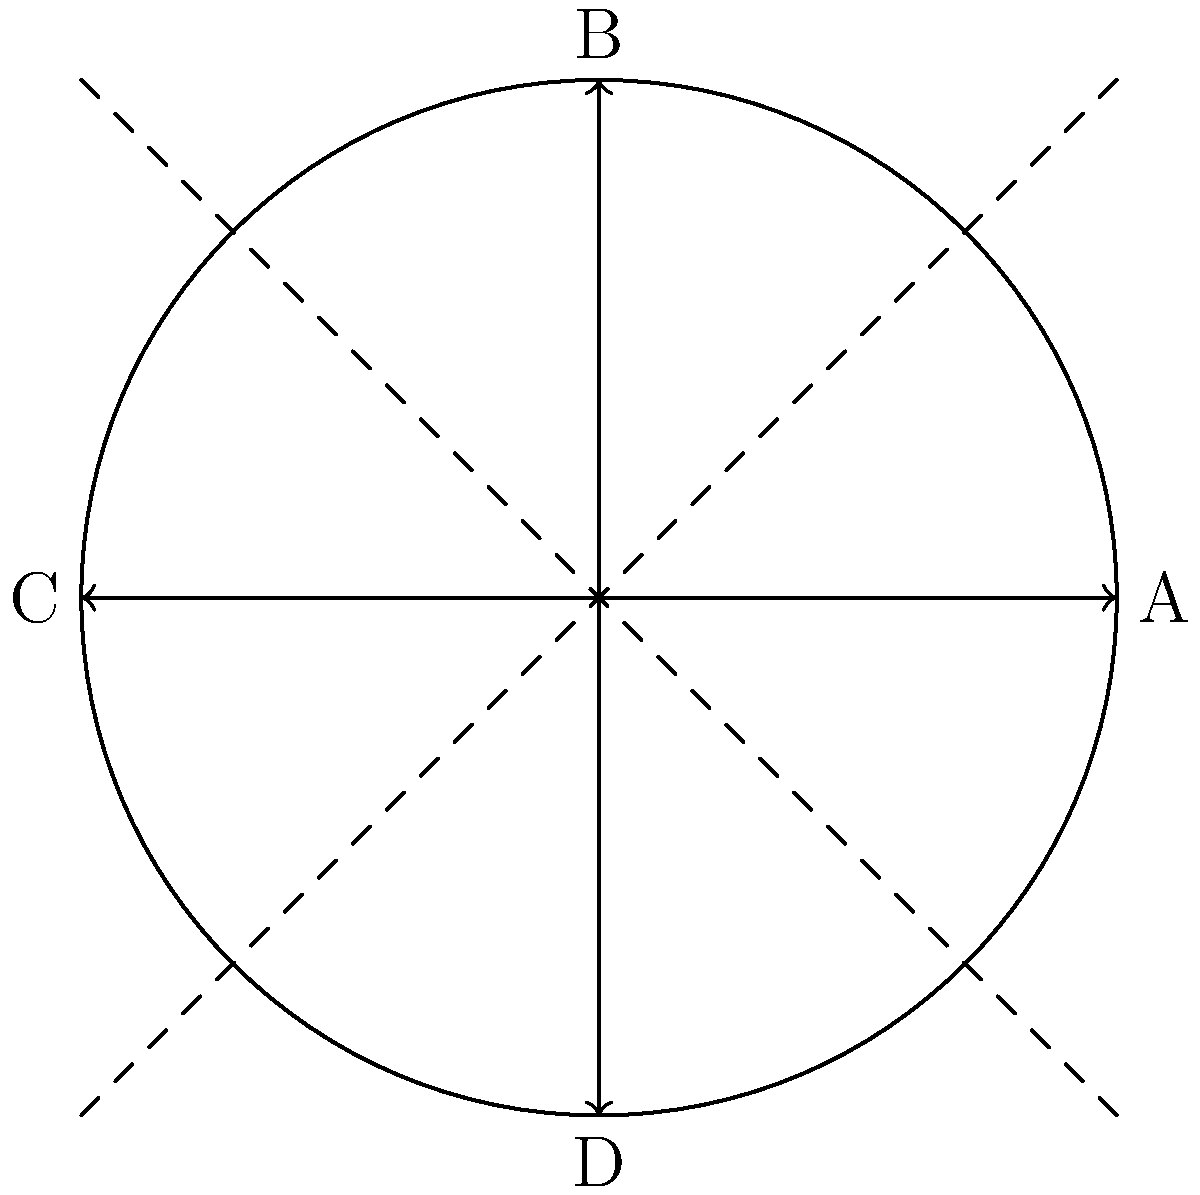Look at the square ABCD inscribed in a circle. How many lines of symmetry does this square have? To find the number of lines of symmetry in a square, let's follow these steps:

1. Recall that a line of symmetry divides a shape into two identical halves.

2. In the given diagram, we can see four potential lines of symmetry:
   a) The vertical line passing through points B and D
   b) The horizontal line passing through points A and C
   c) The diagonal line passing through opposite corners (top-left to bottom-right)
   d) The other diagonal line passing through opposite corners (top-right to bottom-left)

3. Let's verify each of these lines:
   - The vertical line (BD) divides the square into two equal rectangles.
   - The horizontal line (AC) also divides the square into two equal rectangles.
   - Both diagonal lines divide the square into two equal triangles.

4. All four of these lines satisfy the definition of a line of symmetry, as they each divide the square into two identical halves.

5. Therefore, we can conclude that a square has 4 lines of symmetry.

This property is true for all squares, regardless of their size or orientation.
Answer: 4 